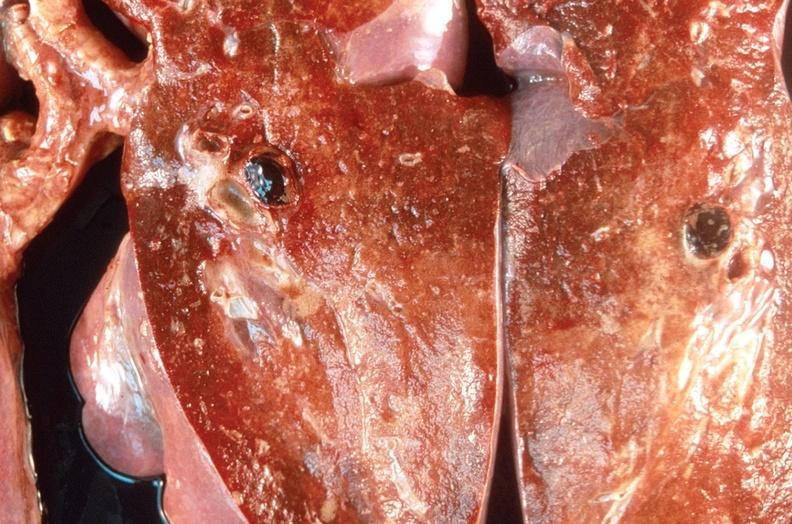what is present?
Answer the question using a single word or phrase. Respiratory 